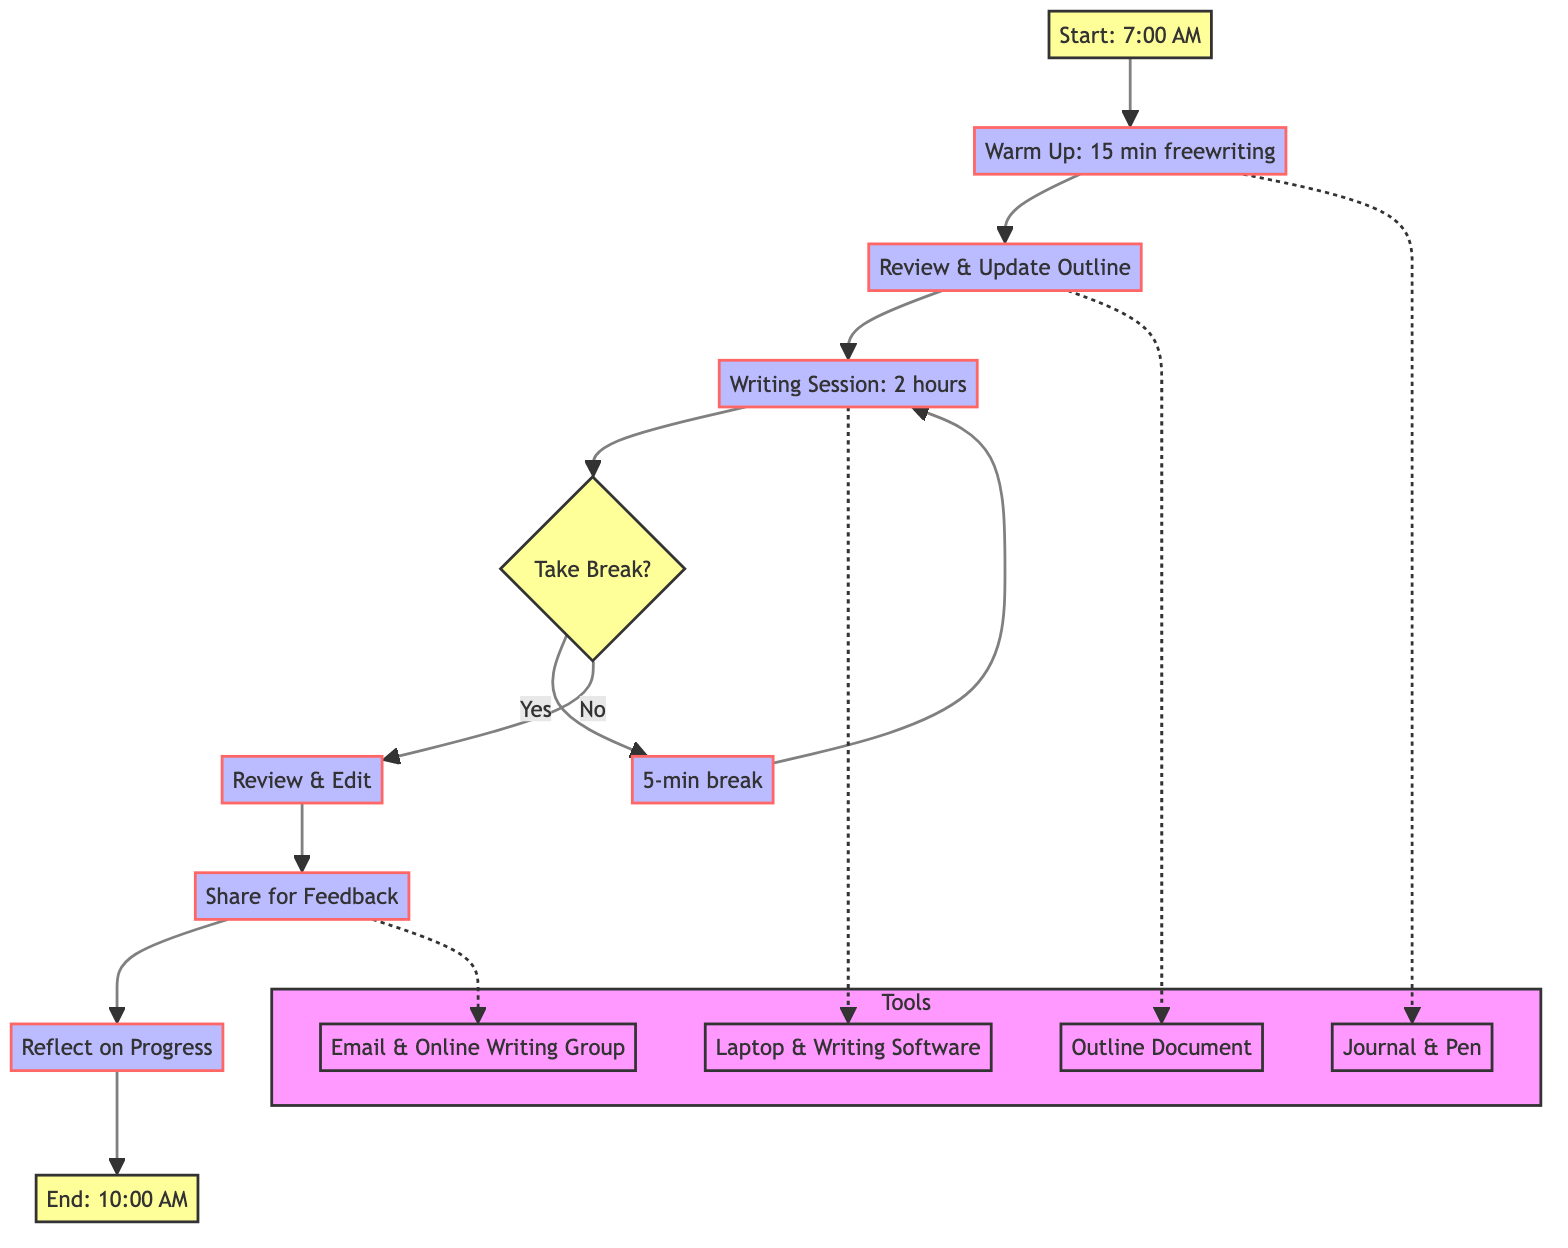What is the start time for the daily writing routine? The diagram specifies that the routine starts at 7:00 AM, indicated in the first node labeled "Start: 7:00 AM".
Answer: 7:00 AM What is the total duration for the writing session? According to the flowchart, the writing session lasts for 2 hours, as noted in the step labeled "Writing Session: 2 hours".
Answer: 2 hours How long should the warm-up period last? The diagram shows that the warm-up period is designated as 15 minutes, stated in the node titled "Warm Up: 15 min freewriting".
Answer: 15 minutes What happens after the writing session if breaks are taken? From the diagram, if breaks are taken after the writing session, it leads to the node labeled "5-min break", which then loops back to "Writing Session: 2 hours".
Answer: 5-min break What tool is associated with the warm-up process? The flowchart indicates "Journal & Pen" as the tools used during the warm-up period, illustrated in the tools subgraph linked to the warm-up node.
Answer: Journal & Pen How many nodes are dedicated to the feedback and reflection phases? The flowchart has two distinct nodes dedicated to feedback and reflection: "Share for Feedback" and "Reflect on Progress", thus making a total of two nodes.
Answer: 2 nodes What is the last activity before ending the writing session? The last activity before concluding the routine involves reflecting on progress, which is indicated by the node "Reflect on Progress".
Answer: Reflect on Progress Which technique is recommended for breaks? The diagram mentions the "Pomodoro Technique" as the method for taking breaks, as referenced in the node labeled "Take Break?".
Answer: Pomodoro Technique What is the purpose of updating the outline? The flowchart describes the purpose of updating the outline as ensuring a clear direction for the day's writing session, which is contained in the node "Review & Update Outline".
Answer: Clear direction 